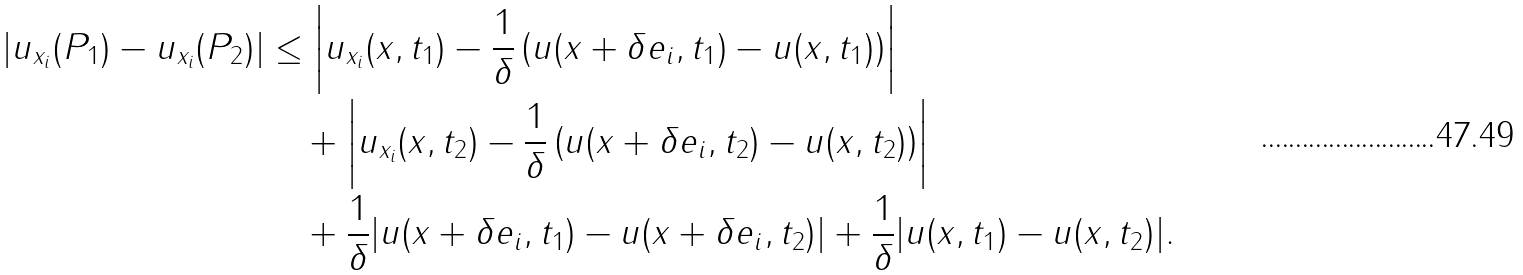<formula> <loc_0><loc_0><loc_500><loc_500>| u _ { x _ { i } } ( P _ { 1 } ) - u _ { x _ { i } } ( P _ { 2 } ) | & \leq \left | u _ { x _ { i } } ( x , t _ { 1 } ) - \frac { 1 } { \delta } \left ( u ( x + \delta e _ { i } , t _ { 1 } ) - u ( x , t _ { 1 } ) \right ) \right | \\ & \quad + \left | u _ { x _ { i } } ( x , t _ { 2 } ) - \frac { 1 } { \delta } \left ( u ( x + \delta e _ { i } , t _ { 2 } ) - u ( x , t _ { 2 } ) \right ) \right | \\ & \quad + \frac { 1 } { \delta } | u ( x + \delta e _ { i } , t _ { 1 } ) - u ( x + \delta e _ { i } , t _ { 2 } ) | + \frac { 1 } { \delta } | u ( x , t _ { 1 } ) - u ( x , t _ { 2 } ) | .</formula> 